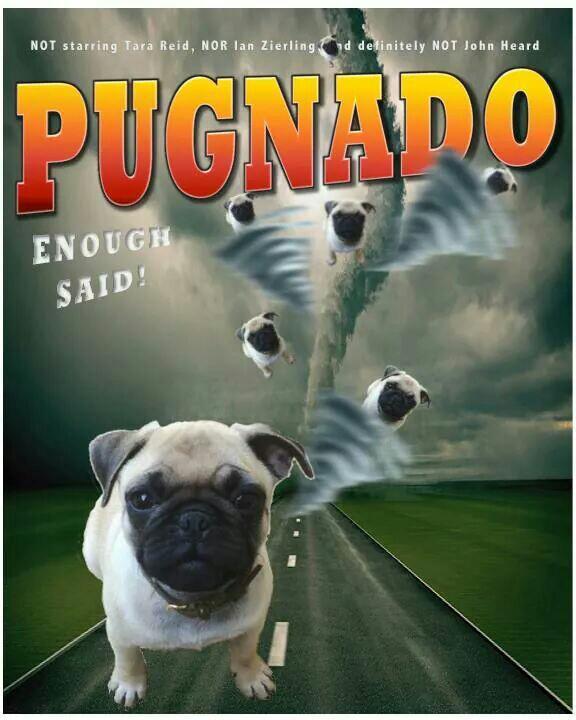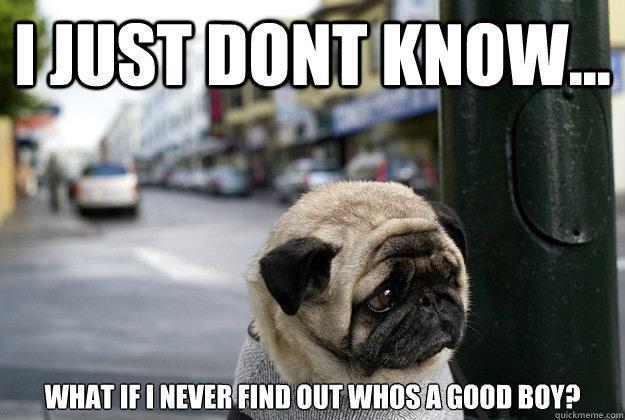The first image is the image on the left, the second image is the image on the right. Analyze the images presented: Is the assertion "There is two dogs in the right image." valid? Answer yes or no. No. The first image is the image on the left, the second image is the image on the right. Assess this claim about the two images: "One image shows a smaller black dog next to a buff-beige pug.". Correct or not? Answer yes or no. No. 